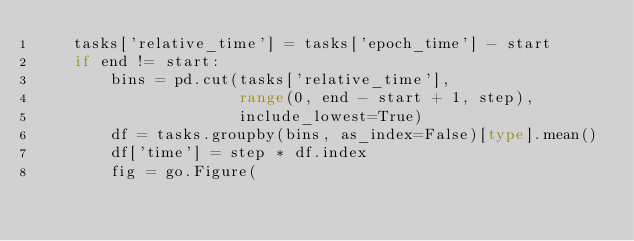Convert code to text. <code><loc_0><loc_0><loc_500><loc_500><_Python_>    tasks['relative_time'] = tasks['epoch_time'] - start
    if end != start:
        bins = pd.cut(tasks['relative_time'],
                      range(0, end - start + 1, step),
                      include_lowest=True)
        df = tasks.groupby(bins, as_index=False)[type].mean()
        df['time'] = step * df.index
        fig = go.Figure(</code> 